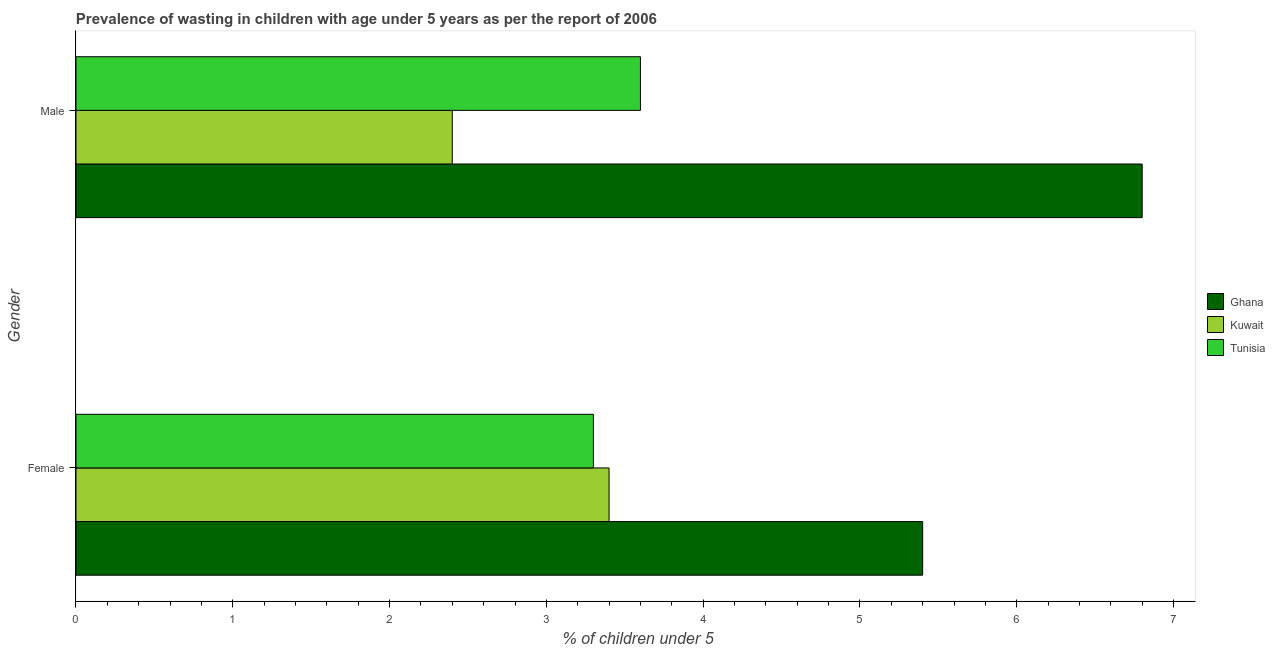How many groups of bars are there?
Your answer should be compact. 2. Are the number of bars per tick equal to the number of legend labels?
Provide a short and direct response. Yes. Are the number of bars on each tick of the Y-axis equal?
Ensure brevity in your answer.  Yes. How many bars are there on the 1st tick from the bottom?
Offer a terse response. 3. What is the percentage of undernourished male children in Kuwait?
Ensure brevity in your answer.  2.4. Across all countries, what is the maximum percentage of undernourished male children?
Your response must be concise. 6.8. Across all countries, what is the minimum percentage of undernourished male children?
Ensure brevity in your answer.  2.4. In which country was the percentage of undernourished male children maximum?
Give a very brief answer. Ghana. In which country was the percentage of undernourished female children minimum?
Make the answer very short. Tunisia. What is the total percentage of undernourished male children in the graph?
Your answer should be very brief. 12.8. What is the difference between the percentage of undernourished male children in Tunisia and that in Ghana?
Give a very brief answer. -3.2. What is the difference between the percentage of undernourished female children in Ghana and the percentage of undernourished male children in Kuwait?
Provide a short and direct response. 3. What is the average percentage of undernourished male children per country?
Make the answer very short. 4.27. In how many countries, is the percentage of undernourished female children greater than 6.6 %?
Ensure brevity in your answer.  0. What is the ratio of the percentage of undernourished male children in Tunisia to that in Ghana?
Ensure brevity in your answer.  0.53. Is the percentage of undernourished female children in Tunisia less than that in Ghana?
Offer a terse response. Yes. In how many countries, is the percentage of undernourished female children greater than the average percentage of undernourished female children taken over all countries?
Your answer should be very brief. 1. What does the 1st bar from the top in Male represents?
Your answer should be compact. Tunisia. What is the difference between two consecutive major ticks on the X-axis?
Provide a short and direct response. 1. Are the values on the major ticks of X-axis written in scientific E-notation?
Offer a very short reply. No. What is the title of the graph?
Provide a succinct answer. Prevalence of wasting in children with age under 5 years as per the report of 2006. What is the label or title of the X-axis?
Offer a terse response.  % of children under 5. What is the  % of children under 5 in Ghana in Female?
Provide a short and direct response. 5.4. What is the  % of children under 5 in Kuwait in Female?
Give a very brief answer. 3.4. What is the  % of children under 5 in Tunisia in Female?
Your answer should be compact. 3.3. What is the  % of children under 5 in Ghana in Male?
Offer a very short reply. 6.8. What is the  % of children under 5 in Kuwait in Male?
Give a very brief answer. 2.4. What is the  % of children under 5 of Tunisia in Male?
Provide a succinct answer. 3.6. Across all Gender, what is the maximum  % of children under 5 in Ghana?
Make the answer very short. 6.8. Across all Gender, what is the maximum  % of children under 5 in Kuwait?
Your answer should be very brief. 3.4. Across all Gender, what is the maximum  % of children under 5 of Tunisia?
Your response must be concise. 3.6. Across all Gender, what is the minimum  % of children under 5 in Ghana?
Offer a terse response. 5.4. Across all Gender, what is the minimum  % of children under 5 of Kuwait?
Offer a very short reply. 2.4. Across all Gender, what is the minimum  % of children under 5 of Tunisia?
Provide a short and direct response. 3.3. What is the total  % of children under 5 in Ghana in the graph?
Your response must be concise. 12.2. What is the total  % of children under 5 of Tunisia in the graph?
Your answer should be compact. 6.9. What is the difference between the  % of children under 5 of Ghana in Female and that in Male?
Give a very brief answer. -1.4. What is the difference between the  % of children under 5 in Kuwait in Female and that in Male?
Your response must be concise. 1. What is the difference between the  % of children under 5 of Tunisia in Female and that in Male?
Provide a succinct answer. -0.3. What is the difference between the  % of children under 5 in Ghana in Female and the  % of children under 5 in Kuwait in Male?
Provide a short and direct response. 3. What is the average  % of children under 5 in Ghana per Gender?
Keep it short and to the point. 6.1. What is the average  % of children under 5 in Kuwait per Gender?
Your answer should be very brief. 2.9. What is the average  % of children under 5 of Tunisia per Gender?
Keep it short and to the point. 3.45. What is the difference between the  % of children under 5 in Ghana and  % of children under 5 in Kuwait in Female?
Your answer should be very brief. 2. What is the difference between the  % of children under 5 in Kuwait and  % of children under 5 in Tunisia in Female?
Keep it short and to the point. 0.1. What is the difference between the  % of children under 5 of Ghana and  % of children under 5 of Kuwait in Male?
Ensure brevity in your answer.  4.4. What is the ratio of the  % of children under 5 in Ghana in Female to that in Male?
Offer a terse response. 0.79. What is the ratio of the  % of children under 5 of Kuwait in Female to that in Male?
Your response must be concise. 1.42. What is the difference between the highest and the second highest  % of children under 5 in Kuwait?
Keep it short and to the point. 1. What is the difference between the highest and the lowest  % of children under 5 of Ghana?
Make the answer very short. 1.4. What is the difference between the highest and the lowest  % of children under 5 in Tunisia?
Your answer should be compact. 0.3. 